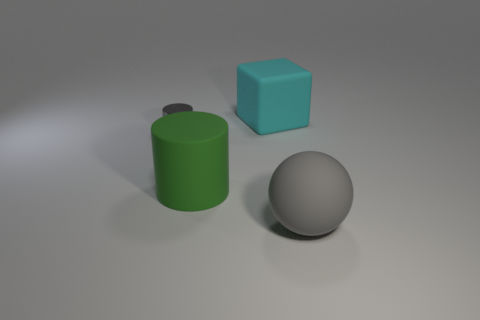What is the shape of the green thing that is made of the same material as the cyan object?
Provide a succinct answer. Cylinder. What number of big objects are gray matte things or green matte cylinders?
Your response must be concise. 2. Is the number of blue matte balls greater than the number of large cyan cubes?
Keep it short and to the point. No. Is the small gray object made of the same material as the cube?
Make the answer very short. No. Are there any other things that have the same material as the small gray cylinder?
Ensure brevity in your answer.  No. Is the number of big cyan matte cubes that are in front of the small cylinder greater than the number of purple metal cubes?
Provide a short and direct response. No. Do the tiny thing and the large cylinder have the same color?
Your answer should be very brief. No. How many gray matte things are the same shape as the cyan object?
Provide a short and direct response. 0. There is a green cylinder that is made of the same material as the cyan cube; what size is it?
Your response must be concise. Large. There is a large rubber thing that is both in front of the large cyan block and right of the large green thing; what color is it?
Ensure brevity in your answer.  Gray. 